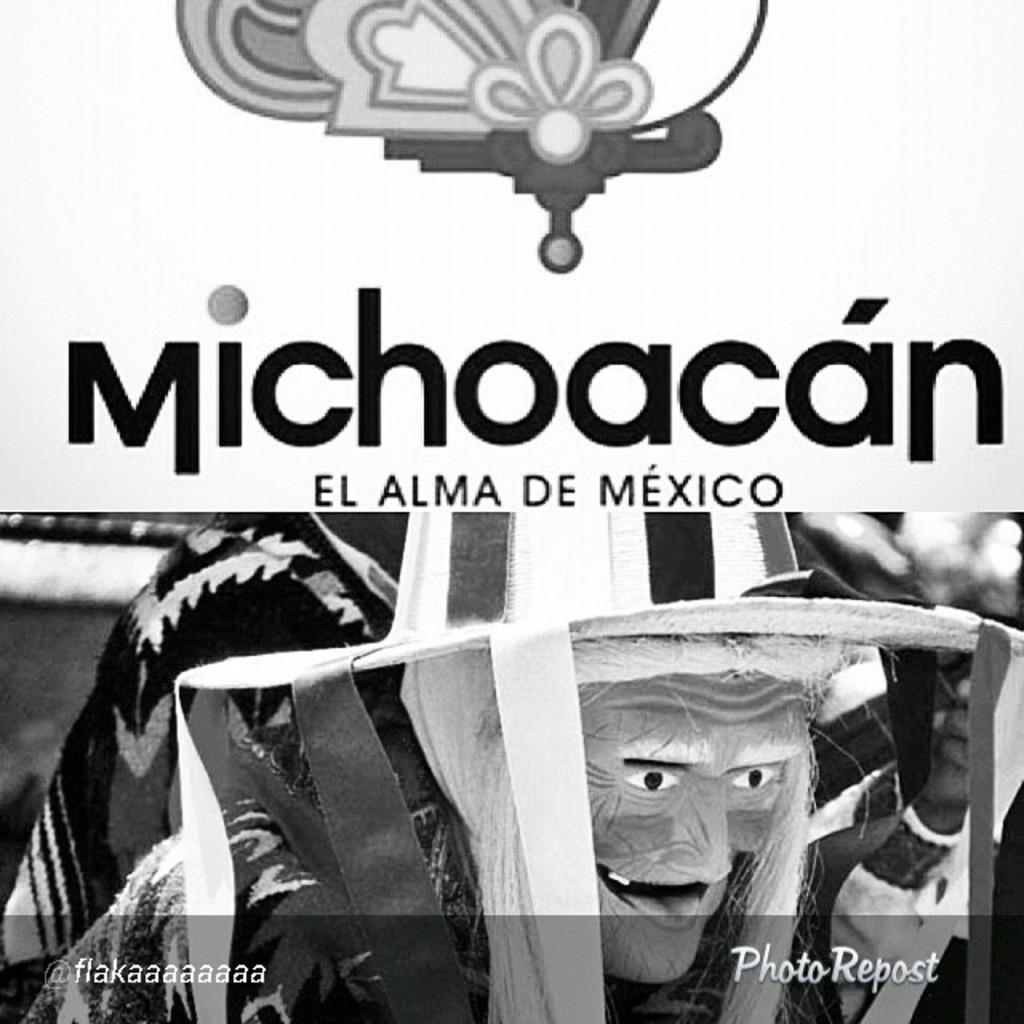What type of visual is the image? The image is a poster. What is the main subject of the poster? There is a person depicted in the poster. What is the person wearing on their face? The person is wearing a mask. What type of headwear is the person wearing? The person is wearing a cap. What else can be found on the poster besides the person? There is text present on the poster. What type of bone is visible in the image? There is no bone visible in the image; it is a poster featuring a person wearing a mask and cap with text. 